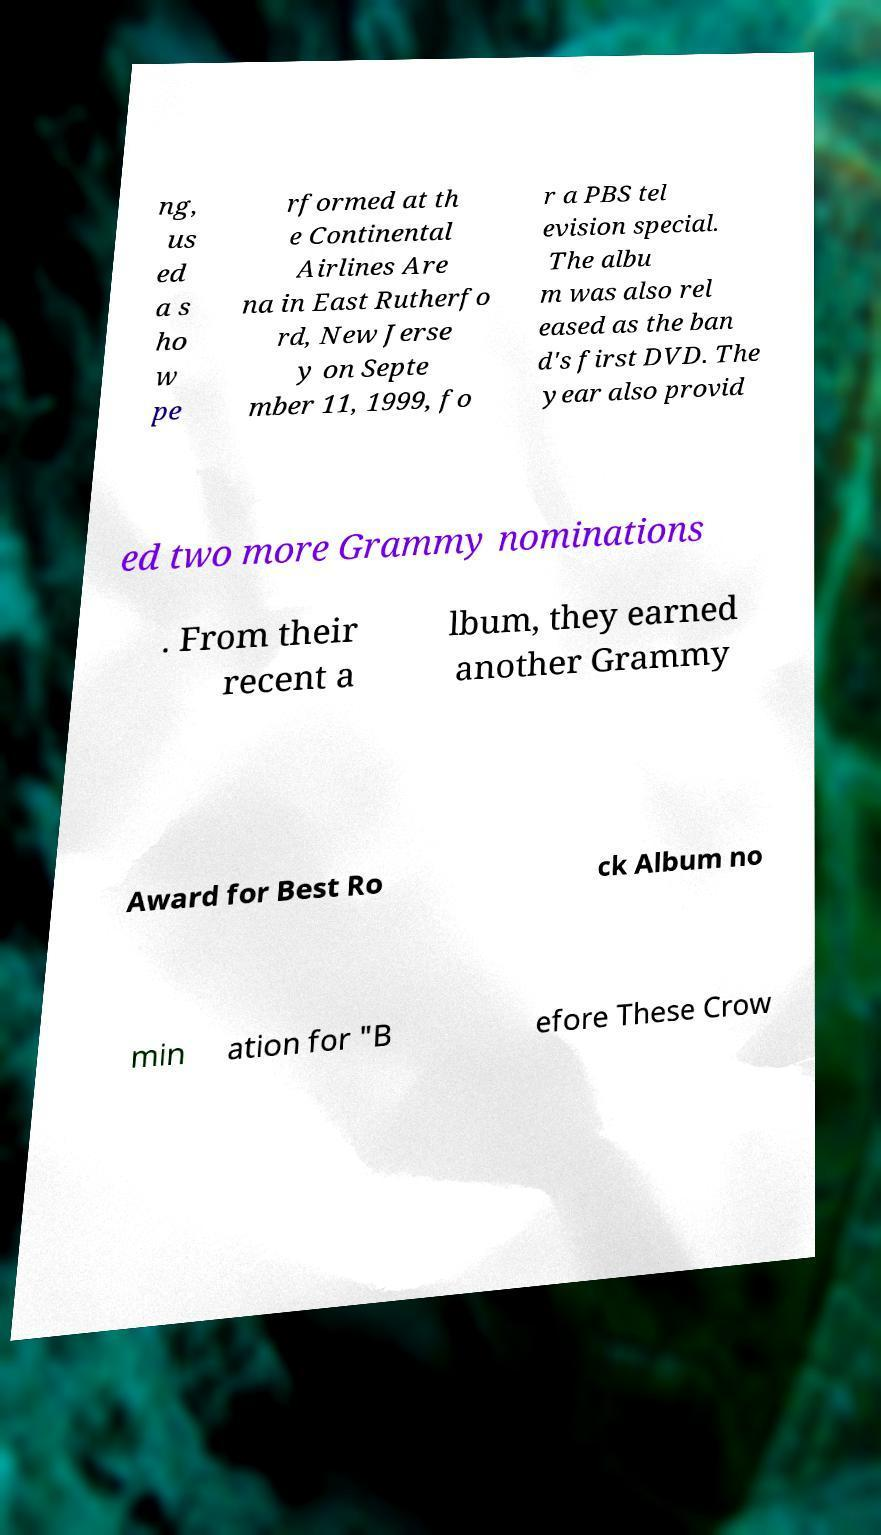For documentation purposes, I need the text within this image transcribed. Could you provide that? ng, us ed a s ho w pe rformed at th e Continental Airlines Are na in East Rutherfo rd, New Jerse y on Septe mber 11, 1999, fo r a PBS tel evision special. The albu m was also rel eased as the ban d's first DVD. The year also provid ed two more Grammy nominations . From their recent a lbum, they earned another Grammy Award for Best Ro ck Album no min ation for "B efore These Crow 